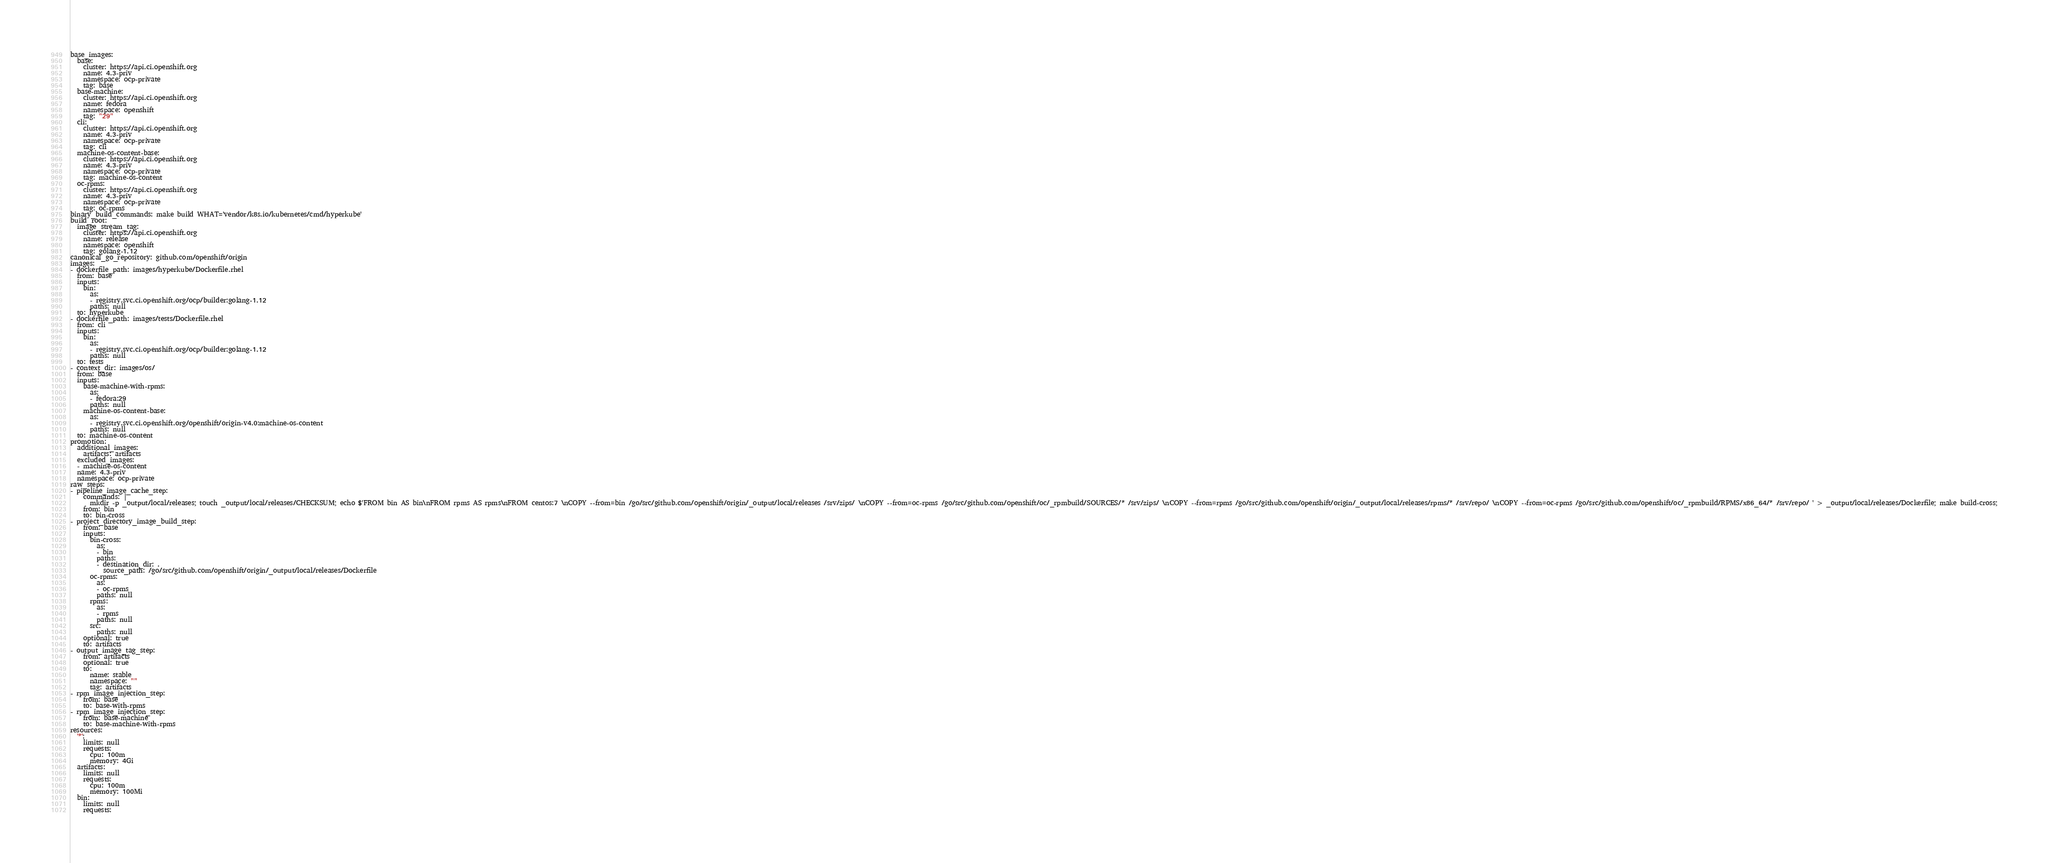Convert code to text. <code><loc_0><loc_0><loc_500><loc_500><_YAML_>base_images:
  base:
    cluster: https://api.ci.openshift.org
    name: 4.3-priv
    namespace: ocp-private
    tag: base
  base-machine:
    cluster: https://api.ci.openshift.org
    name: fedora
    namespace: openshift
    tag: "29"
  cli:
    cluster: https://api.ci.openshift.org
    name: 4.3-priv
    namespace: ocp-private
    tag: cli
  machine-os-content-base:
    cluster: https://api.ci.openshift.org
    name: 4.3-priv
    namespace: ocp-private
    tag: machine-os-content
  oc-rpms:
    cluster: https://api.ci.openshift.org
    name: 4.3-priv
    namespace: ocp-private
    tag: oc-rpms
binary_build_commands: make build WHAT='vendor/k8s.io/kubernetes/cmd/hyperkube'
build_root:
  image_stream_tag:
    cluster: https://api.ci.openshift.org
    name: release
    namespace: openshift
    tag: golang-1.12
canonical_go_repository: github.com/openshift/origin
images:
- dockerfile_path: images/hyperkube/Dockerfile.rhel
  from: base
  inputs:
    bin:
      as:
      - registry.svc.ci.openshift.org/ocp/builder:golang-1.12
      paths: null
  to: hyperkube
- dockerfile_path: images/tests/Dockerfile.rhel
  from: cli
  inputs:
    bin:
      as:
      - registry.svc.ci.openshift.org/ocp/builder:golang-1.12
      paths: null
  to: tests
- context_dir: images/os/
  from: base
  inputs:
    base-machine-with-rpms:
      as:
      - fedora:29
      paths: null
    machine-os-content-base:
      as:
      - registry.svc.ci.openshift.org/openshift/origin-v4.0:machine-os-content
      paths: null
  to: machine-os-content
promotion:
  additional_images:
    artifacts: artifacts
  excluded_images:
  - machine-os-content
  name: 4.3-priv
  namespace: ocp-private
raw_steps:
- pipeline_image_cache_step:
    commands: |
      mkdir -p _output/local/releases; touch _output/local/releases/CHECKSUM; echo $'FROM bin AS bin\nFROM rpms AS rpms\nFROM centos:7 \nCOPY --from=bin /go/src/github.com/openshift/origin/_output/local/releases /srv/zips/ \nCOPY --from=oc-rpms /go/src/github.com/openshift/oc/_rpmbuild/SOURCES/* /srv/zips/ \nCOPY --from=rpms /go/src/github.com/openshift/origin/_output/local/releases/rpms/* /srv/repo/ \nCOPY --from=oc-rpms /go/src/github.com/openshift/oc/_rpmbuild/RPMS/x86_64/* /srv/repo/ ' > _output/local/releases/Dockerfile; make build-cross;
    from: bin
    to: bin-cross
- project_directory_image_build_step:
    from: base
    inputs:
      bin-cross:
        as:
        - bin
        paths:
        - destination_dir: .
          source_path: /go/src/github.com/openshift/origin/_output/local/releases/Dockerfile
      oc-rpms:
        as:
        - oc-rpms
        paths: null
      rpms:
        as:
        - rpms
        paths: null
      src:
        paths: null
    optional: true
    to: artifacts
- output_image_tag_step:
    from: artifacts
    optional: true
    to:
      name: stable
      namespace: ""
      tag: artifacts
- rpm_image_injection_step:
    from: base
    to: base-with-rpms
- rpm_image_injection_step:
    from: base-machine
    to: base-machine-with-rpms
resources:
  '*':
    limits: null
    requests:
      cpu: 100m
      memory: 4Gi
  artifacts:
    limits: null
    requests:
      cpu: 100m
      memory: 100Mi
  bin:
    limits: null
    requests:</code> 